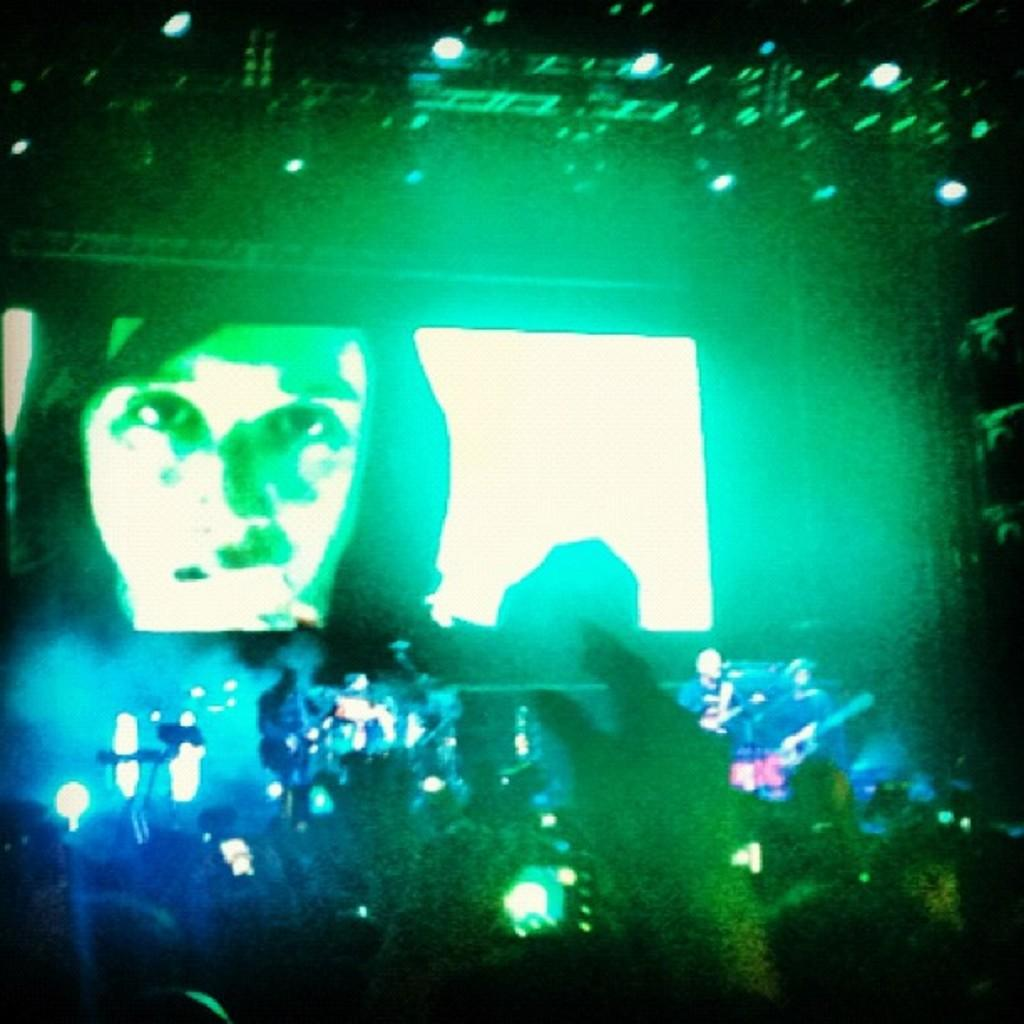What are the people in the front of the image doing? The people in the front of the image are playing musical instruments. Are there any other people playing musical instruments in the image? Yes, there are people playing musical instruments at the back of the image. What can be seen in the image that provides illumination? There are lights visible in the image. What object is present in the image that might display visual content? There is a screen present in the image. What type of loaf is being used as a drumstick by the carpenter in the image? There is no carpenter or loaf present in the image. What does the person in the image need to continue playing their instrument? The question cannot be answered definitively from the provided facts, as it assumes a need that may not be present in the image. 